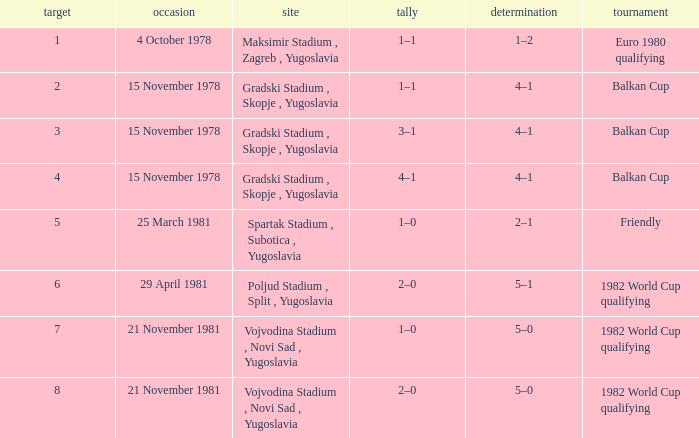What is the Result for Goal 3? 4–1. Help me parse the entirety of this table. {'header': ['target', 'occasion', 'site', 'tally', 'determination', 'tournament'], 'rows': [['1', '4 October 1978', 'Maksimir Stadium , Zagreb , Yugoslavia', '1–1', '1–2', 'Euro 1980 qualifying'], ['2', '15 November 1978', 'Gradski Stadium , Skopje , Yugoslavia', '1–1', '4–1', 'Balkan Cup'], ['3', '15 November 1978', 'Gradski Stadium , Skopje , Yugoslavia', '3–1', '4–1', 'Balkan Cup'], ['4', '15 November 1978', 'Gradski Stadium , Skopje , Yugoslavia', '4–1', '4–1', 'Balkan Cup'], ['5', '25 March 1981', 'Spartak Stadium , Subotica , Yugoslavia', '1–0', '2–1', 'Friendly'], ['6', '29 April 1981', 'Poljud Stadium , Split , Yugoslavia', '2–0', '5–1', '1982 World Cup qualifying'], ['7', '21 November 1981', 'Vojvodina Stadium , Novi Sad , Yugoslavia', '1–0', '5–0', '1982 World Cup qualifying'], ['8', '21 November 1981', 'Vojvodina Stadium , Novi Sad , Yugoslavia', '2–0', '5–0', '1982 World Cup qualifying']]} 